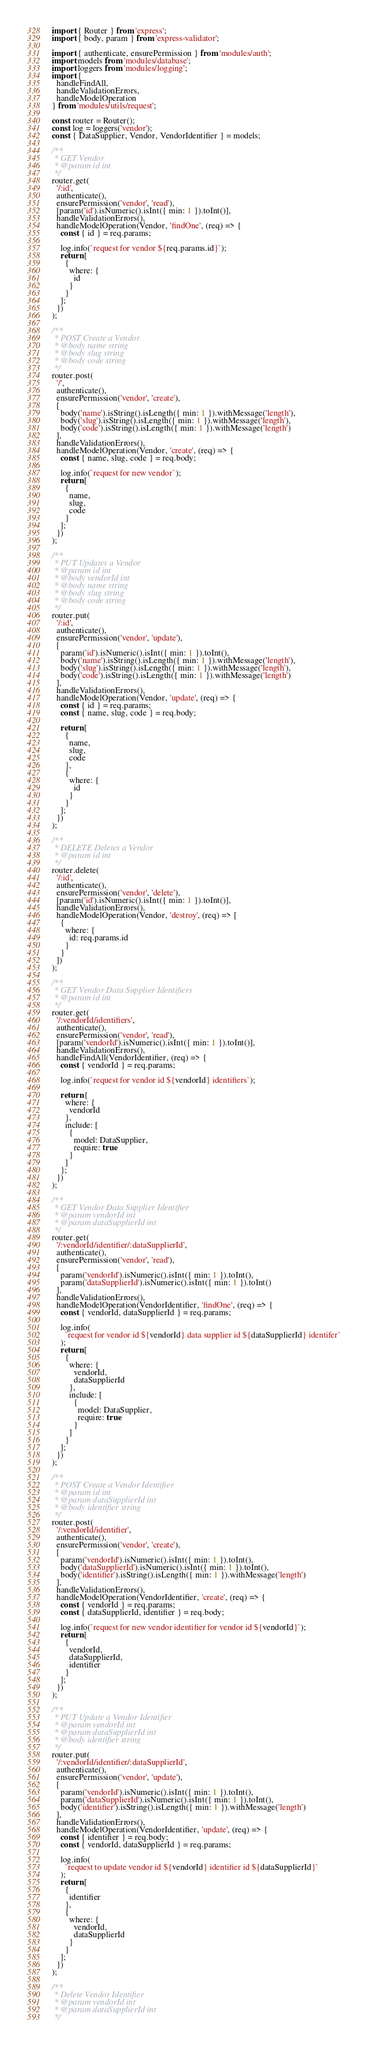<code> <loc_0><loc_0><loc_500><loc_500><_JavaScript_>import { Router } from 'express';
import { body, param } from 'express-validator';

import { authenticate, ensurePermission } from 'modules/auth';
import models from 'modules/database';
import loggers from 'modules/logging';
import {
  handleFindAll,
  handleValidationErrors,
  handleModelOperation
} from 'modules/utils/request';

const router = Router();
const log = loggers('vendor');
const { DataSupplier, Vendor, VendorIdentifier } = models;

/**
 * GET Vendor
 * @param id int
 */
router.get(
  '/:id',
  authenticate(),
  ensurePermission('vendor', 'read'),
  [param('id').isNumeric().isInt({ min: 1 }).toInt()],
  handleValidationErrors(),
  handleModelOperation(Vendor, 'findOne', (req) => {
    const { id } = req.params;

    log.info(`request for vendor ${req.params.id}`);
    return [
      {
        where: {
          id
        }
      }
    ];
  })
);

/**
 * POST Create a Vendor
 * @body name string
 * @body slug string
 * @body code string
 */
router.post(
  '/',
  authenticate(),
  ensurePermission('vendor', 'create'),
  [
    body('name').isString().isLength({ min: 1 }).withMessage('length'),
    body('slug').isString().isLength({ min: 1 }).withMessage('length'),
    body('code').isString().isLength({ min: 1 }).withMessage('length')
  ],
  handleValidationErrors(),
  handleModelOperation(Vendor, 'create', (req) => {
    const { name, slug, code } = req.body;

    log.info(`request for new vendor`);
    return [
      {
        name,
        slug,
        code
      }
    ];
  })
);

/**
 * PUT Updates a Vendor
 * @param id int
 * @body vendorId int
 * @body name string
 * @body slug string
 * @body code string
 */
router.put(
  '/:id',
  authenticate(),
  ensurePermission('vendor', 'update'),
  [
    param('id').isNumeric().isInt({ min: 1 }).toInt(),
    body('name').isString().isLength({ min: 1 }).withMessage('length'),
    body('slug').isString().isLength({ min: 1 }).withMessage('length'),
    body('code').isString().isLength({ min: 1 }).withMessage('length')
  ],
  handleValidationErrors(),
  handleModelOperation(Vendor, 'update', (req) => {
    const { id } = req.params;
    const { name, slug, code } = req.body;

    return [
      {
        name,
        slug,
        code
      },
      {
        where: {
          id
        }
      }
    ];
  })
);

/**
 * DELETE Deletes a Vendor
 * @param id int
 */
router.delete(
  '/:id',
  authenticate(),
  ensurePermission('vendor', 'delete'),
  [param('id').isNumeric().isInt({ min: 1 }).toInt()],
  handleValidationErrors(),
  handleModelOperation(Vendor, 'destroy', (req) => [
    {
      where: {
        id: req.params.id
      }
    }
  ])
);

/**
 * GET Vendor Data Supplier Identifiers
 * @param id int
 */
router.get(
  '/:vendorId/identifiers',
  authenticate(),
  ensurePermission('vendor', 'read'),
  [param('vendorId').isNumeric().isInt({ min: 1 }).toInt()],
  handleValidationErrors(),
  handleFindAll(VendorIdentifier, (req) => {
    const { vendorId } = req.params;

    log.info(`request for vendor id ${vendorId} identifiers`);

    return {
      where: {
        vendorId
      },
      include: [
        {
          model: DataSupplier,
          require: true
        }
      ]
    };
  })
);

/**
 * GET Vendor Data Supplier Identifier
 * @param vendorId int
 * @param dataSupplierId int
 */
router.get(
  '/:vendorId/identifier/:dataSupplierId',
  authenticate(),
  ensurePermission('vendor', 'read'),
  [
    param('vendorId').isNumeric().isInt({ min: 1 }).toInt(),
    param('dataSupplierId').isNumeric().isInt({ min: 1 }).toInt()
  ],
  handleValidationErrors(),
  handleModelOperation(VendorIdentifier, 'findOne', (req) => {
    const { vendorId, dataSupplierId } = req.params;

    log.info(
      `request for vendor id ${vendorId} data supplier id ${dataSupplierId} identifer`
    );
    return [
      {
        where: {
          vendorId,
          dataSupplierId
        },
        include: [
          {
            model: DataSupplier,
            require: true
          }
        ]
      }
    ];
  })
);

/**
 * POST Create a Vendor Identifier
 * @param id int
 * @param dataSupplierId int
 * @body identifier string
 */
router.post(
  '/:vendorId/identifier',
  authenticate(),
  ensurePermission('vendor', 'create'),
  [
    param('vendorId').isNumeric().isInt({ min: 1 }).toInt(),
    body('dataSupplierId').isNumeric().isInt({ min: 1 }).toInt(),
    body('identifier').isString().isLength({ min: 1 }).withMessage('length')
  ],
  handleValidationErrors(),
  handleModelOperation(VendorIdentifier, 'create', (req) => {
    const { vendorId } = req.params;
    const { dataSupplierId, identifier } = req.body;

    log.info(`request for new vendor identifier for vendor id ${vendorId}`);
    return [
      {
        vendorId,
        dataSupplierId,
        identifier
      }
    ];
  })
);

/**
 * PUT Update a Vendor Identifier
 * @param vendorId int
 * @param dataSupplierId int
 * @body identifier string
 */
router.put(
  '/:vendorId/identifier/:dataSupplierId',
  authenticate(),
  ensurePermission('vendor', 'update'),
  [
    param('vendorId').isNumeric().isInt({ min: 1 }).toInt(),
    param('dataSupplierId').isNumeric().isInt({ min: 1 }).toInt(),
    body('identifier').isString().isLength({ min: 1 }).withMessage('length')
  ],
  handleValidationErrors(),
  handleModelOperation(VendorIdentifier, 'update', (req) => {
    const { identifier } = req.body;
    const { vendorId, dataSupplierId } = req.params;

    log.info(
      `request to update vendor id ${vendorId} identifier id ${dataSupplierId}`
    );
    return [
      {
        identifier
      },
      {
        where: {
          vendorId,
          dataSupplierId
        }
      }
    ];
  })
);

/**
 * Delete Vendor Identifier
 * @param vendorId int
 * @param dataSupplierId int
 */</code> 